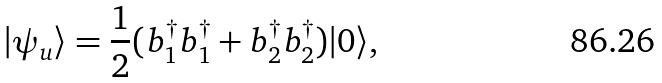<formula> <loc_0><loc_0><loc_500><loc_500>| \psi _ { u } \rangle = \frac { 1 } { 2 } ( b ^ { \dag } _ { 1 } b ^ { \dag } _ { 1 } + b ^ { \dag } _ { 2 } b ^ { \dag } _ { 2 } ) | 0 \rangle ,</formula> 